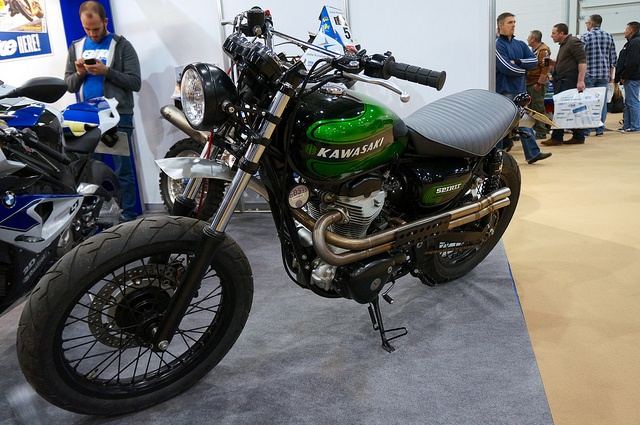Describe the objects in this image and their specific colors. I can see motorcycle in yellow, black, gray, darkgray, and lightgray tones, motorcycle in yellow, black, gray, darkgray, and lightgray tones, people in yellow, black, gray, navy, and lightgray tones, people in yellow, black, gray, lightgray, and darkgray tones, and people in yellow, black, navy, darkblue, and gray tones in this image. 